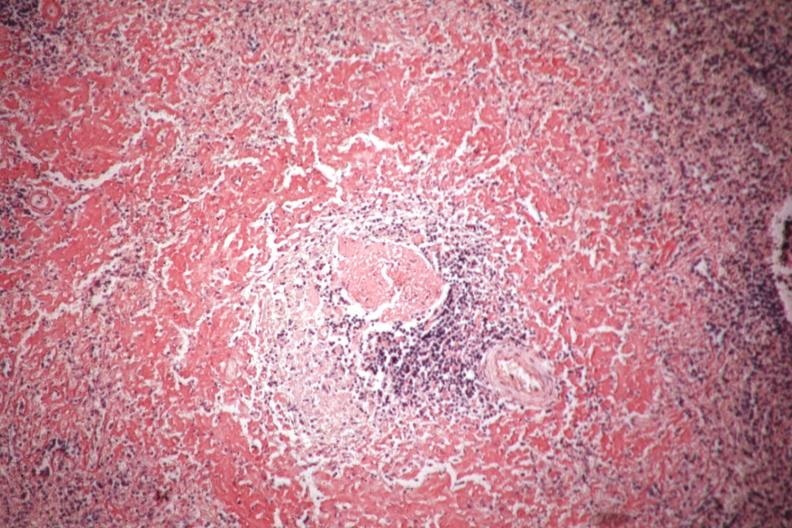s hematologic present?
Answer the question using a single word or phrase. Yes 